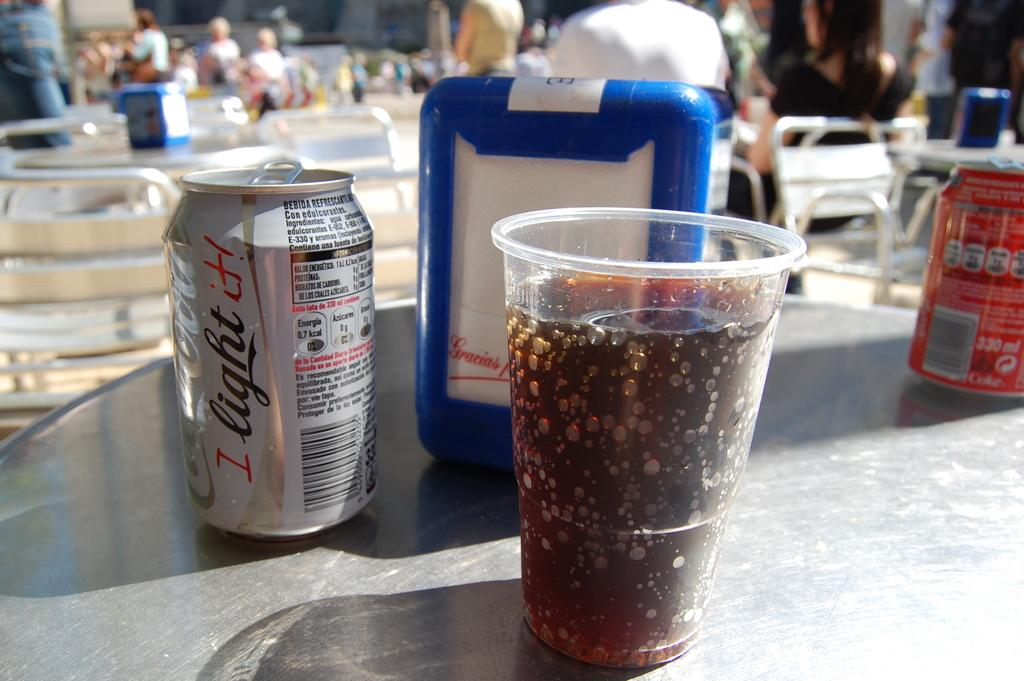Provide a one-sentence caption for the provided image. A table with a cup of soda on it and a can of diet coca cola in the background. 